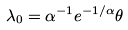Convert formula to latex. <formula><loc_0><loc_0><loc_500><loc_500>\lambda _ { 0 } = \alpha ^ { - 1 } e ^ { - 1 / \alpha } \theta</formula> 